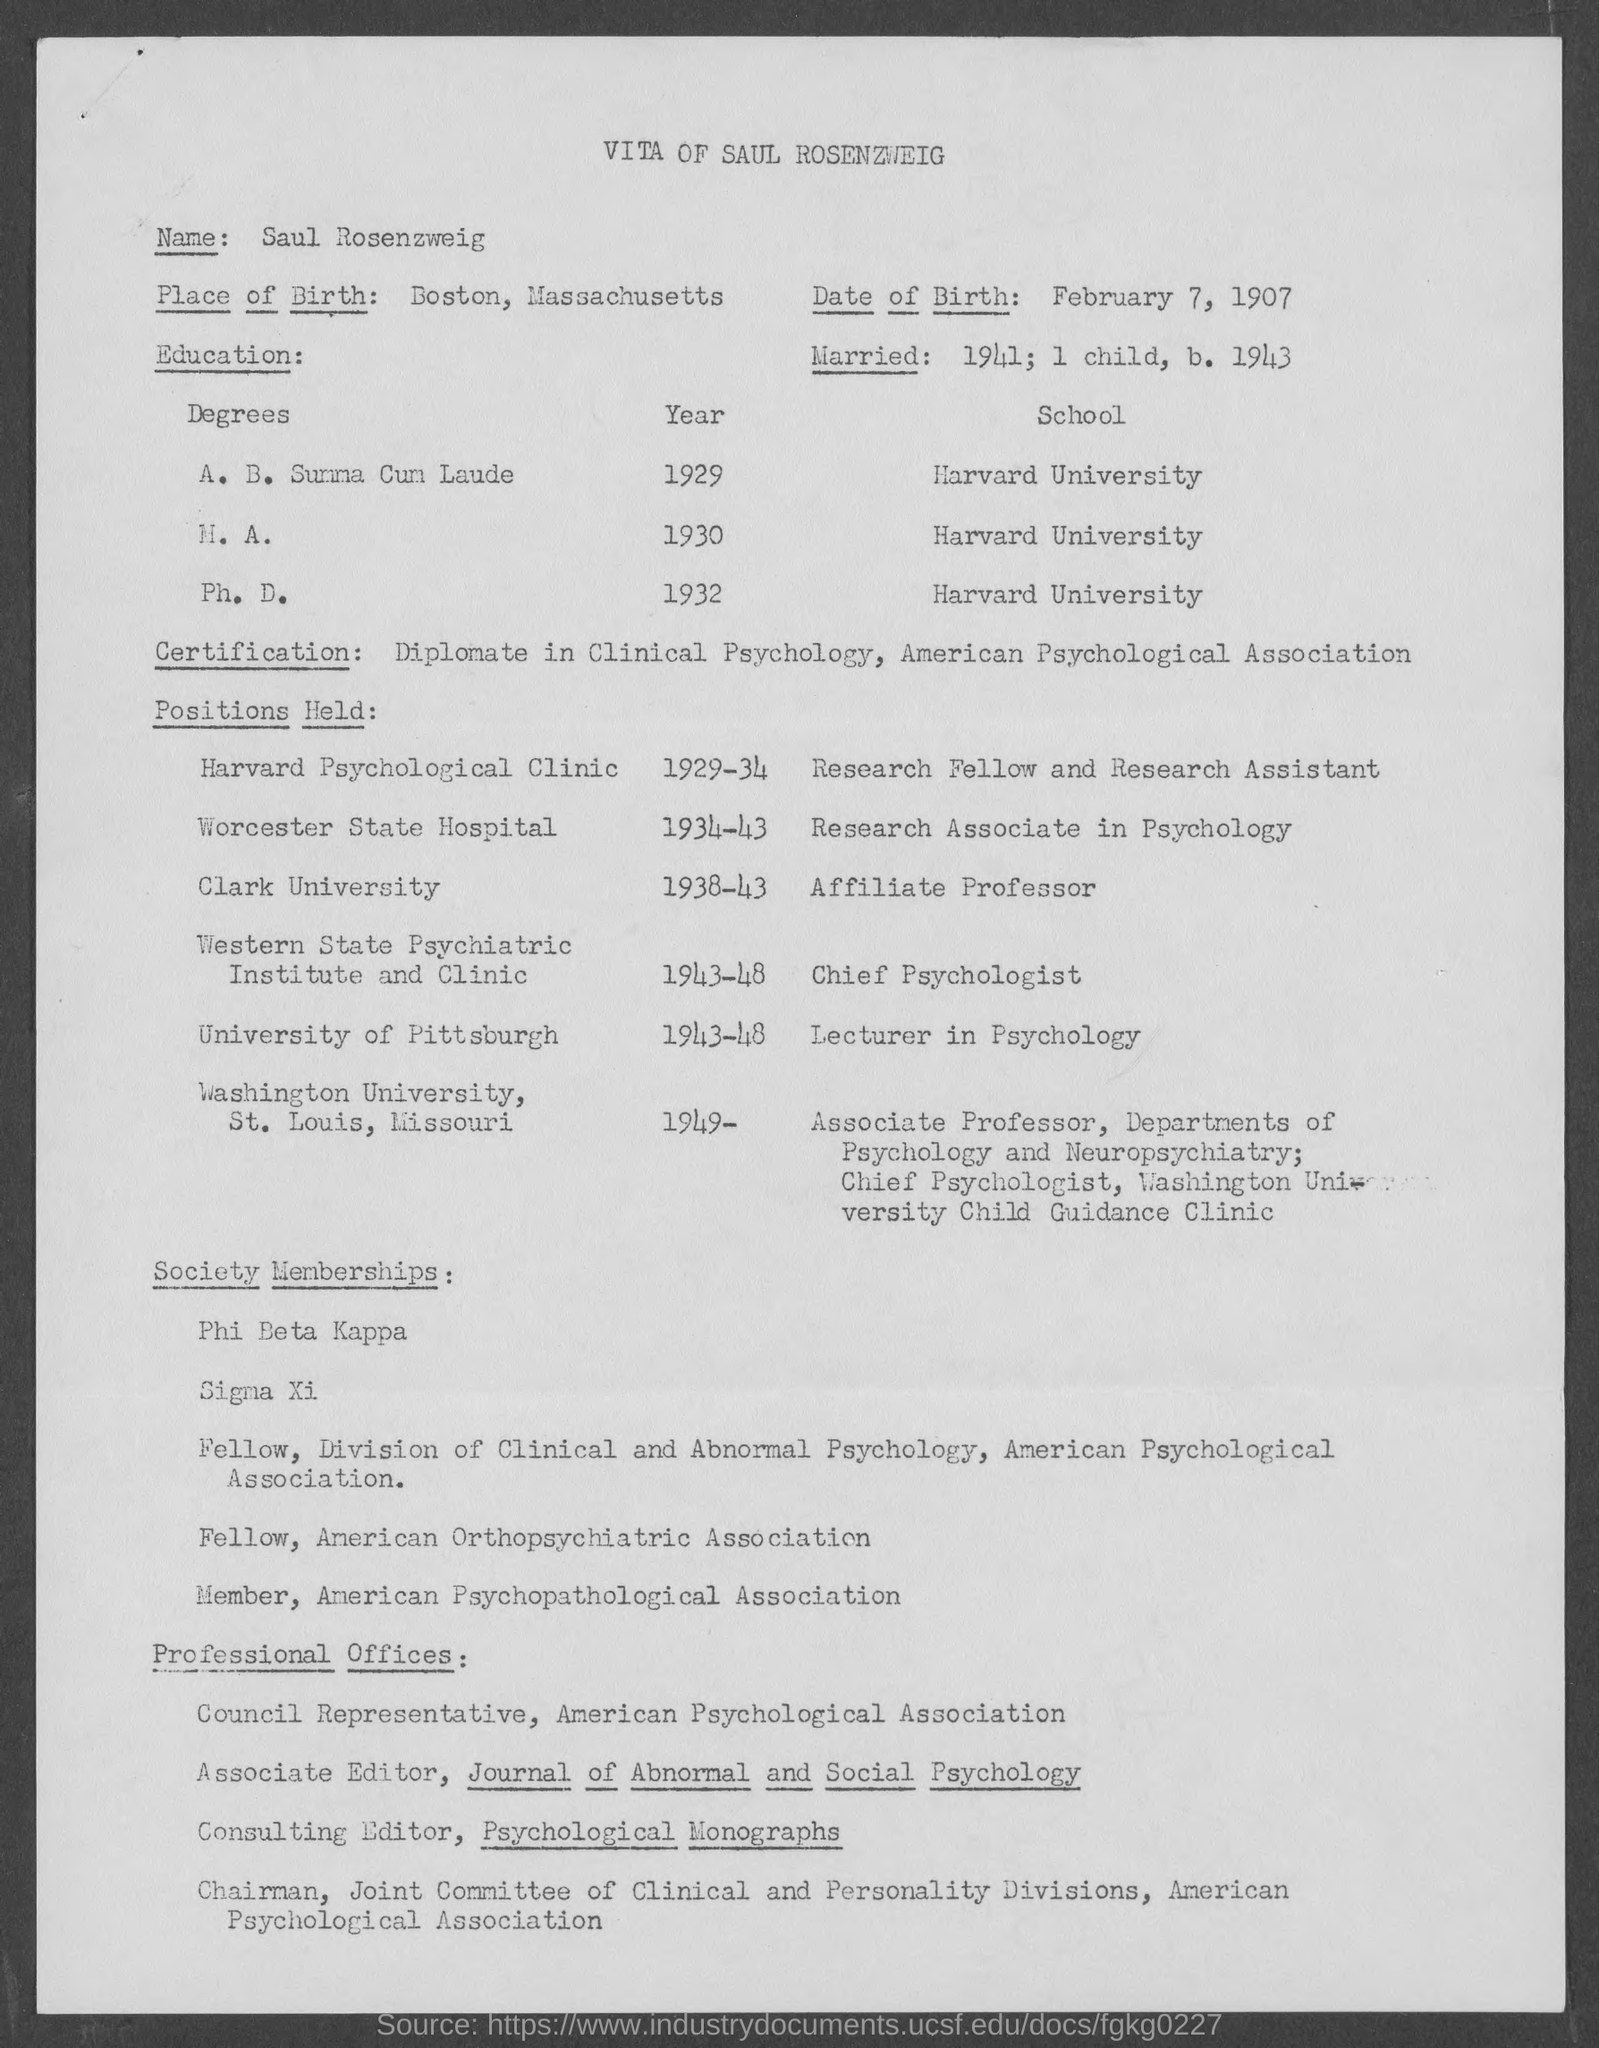On which year he had married? According to the document in the image, he was married in the year 1941 and had a child by 1943. 